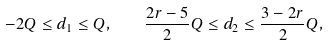<formula> <loc_0><loc_0><loc_500><loc_500>- 2 Q \leq d _ { 1 } \leq Q , \quad \frac { 2 r - 5 } { 2 } Q \leq d _ { 2 } \leq \frac { 3 - 2 r } { 2 } Q ,</formula> 